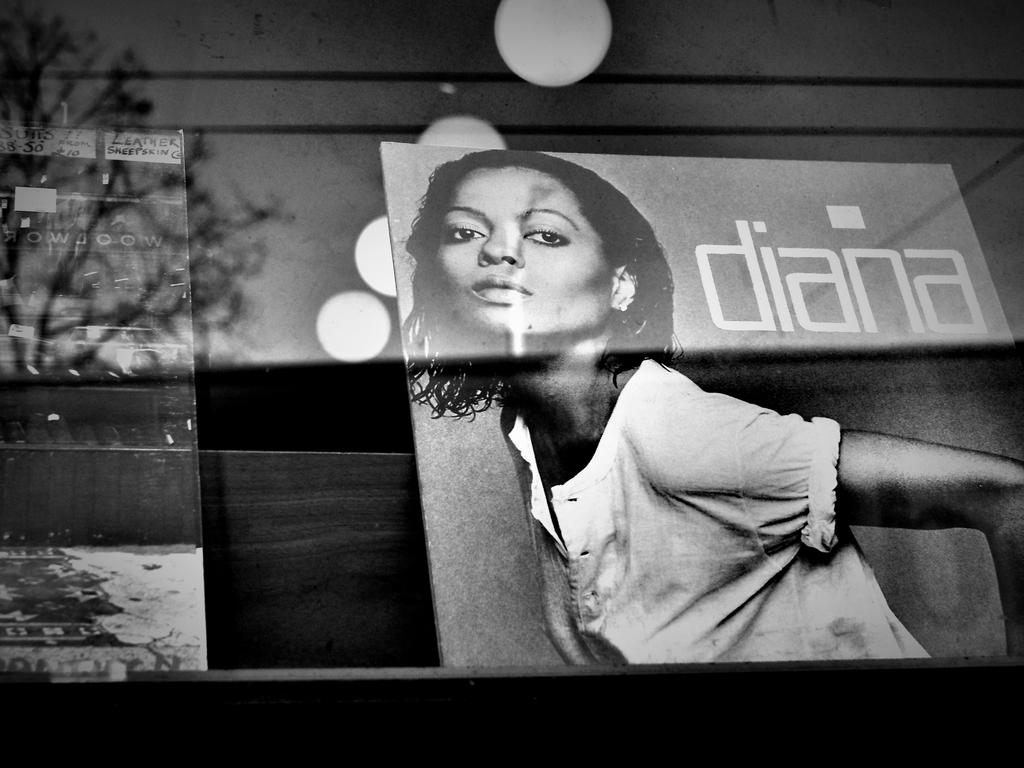What is located on the rack in the image? There are posters on a rack in the image. Can you describe the image on the right side of the rack? There is a picture of a woman on the right side of the rack. What can be seen in the background of the image? There is a wall in the background of the image. What type of material is the rack made of? The wooden rack is at the bottom of the image. How much debt do the men owe in the image? There are no men or mention of debt in the image; it features a rack of posters with a picture of a woman. What type of yard is visible in the image? There is no yard visible in the image; it features a rack of posters with a picture of a woman and a wall in the background. 